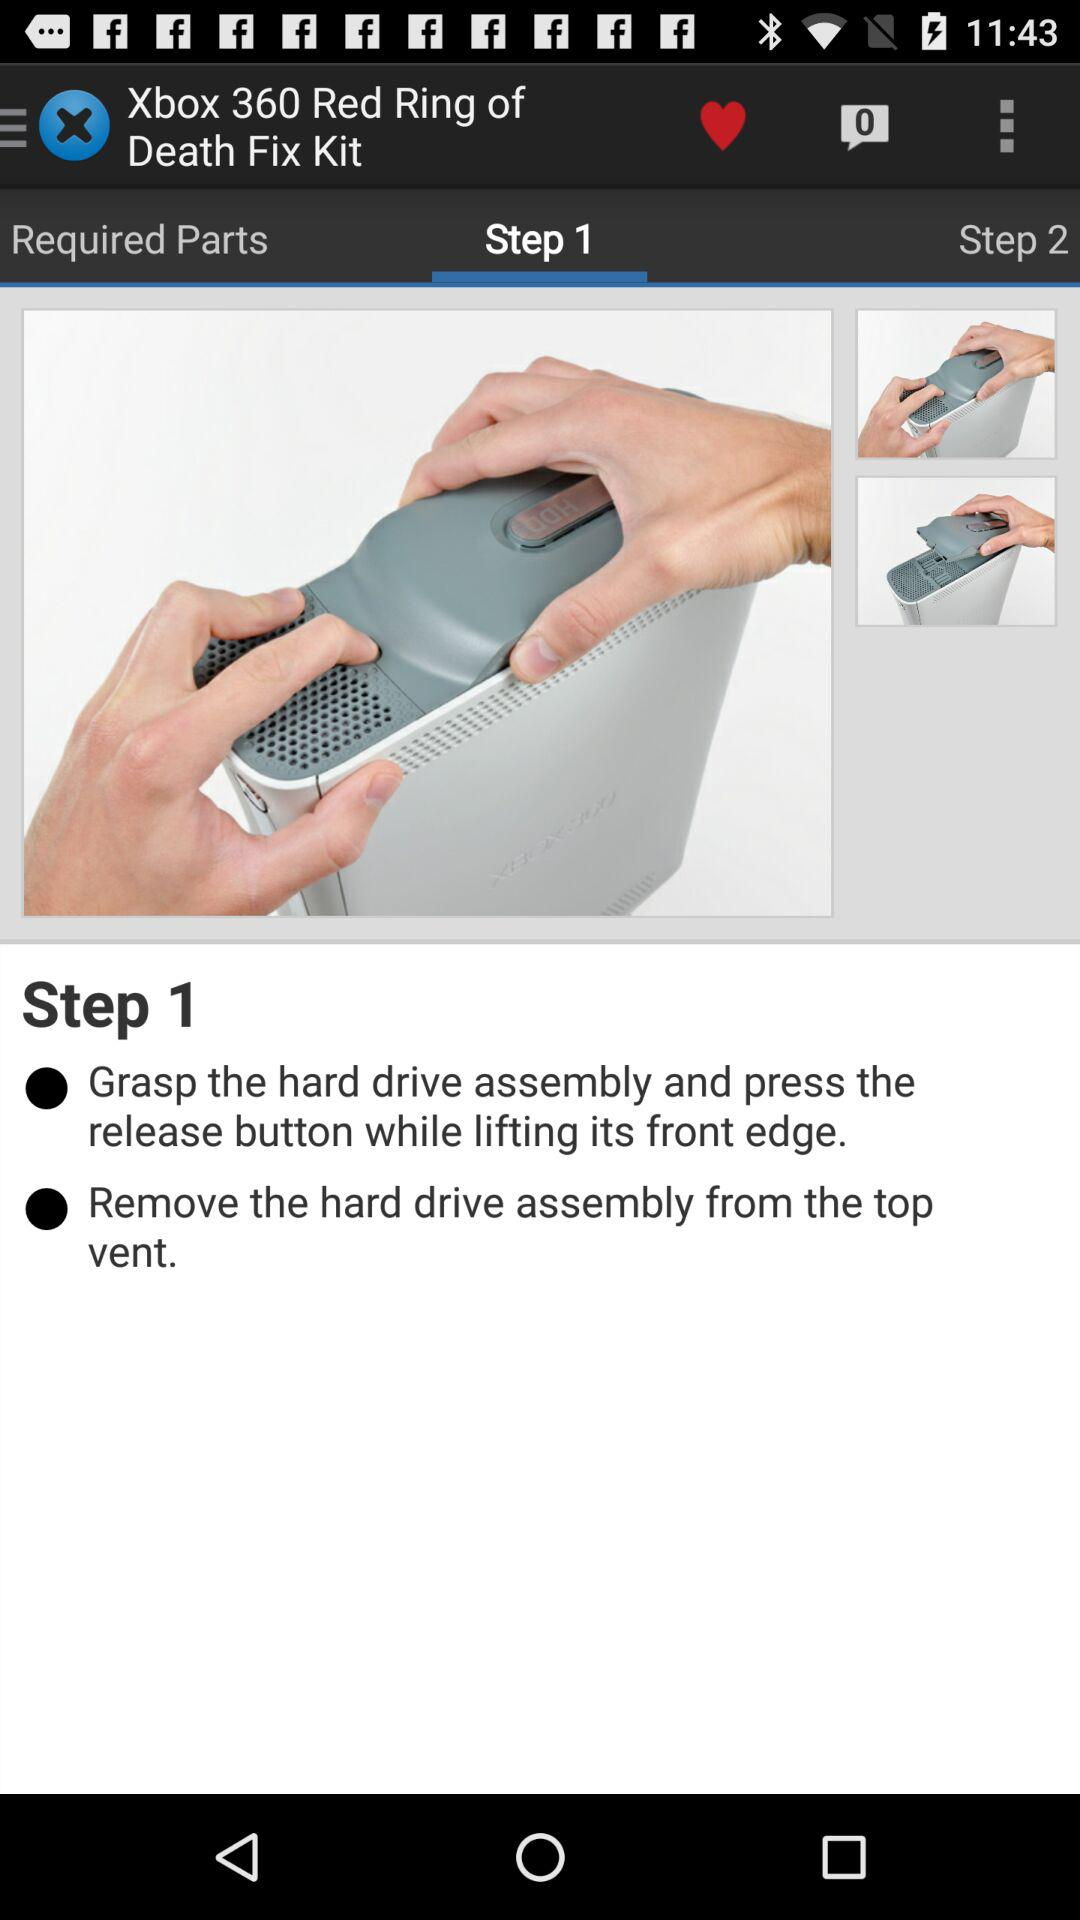How many steps are there in the process?
Answer the question using a single word or phrase. 2 